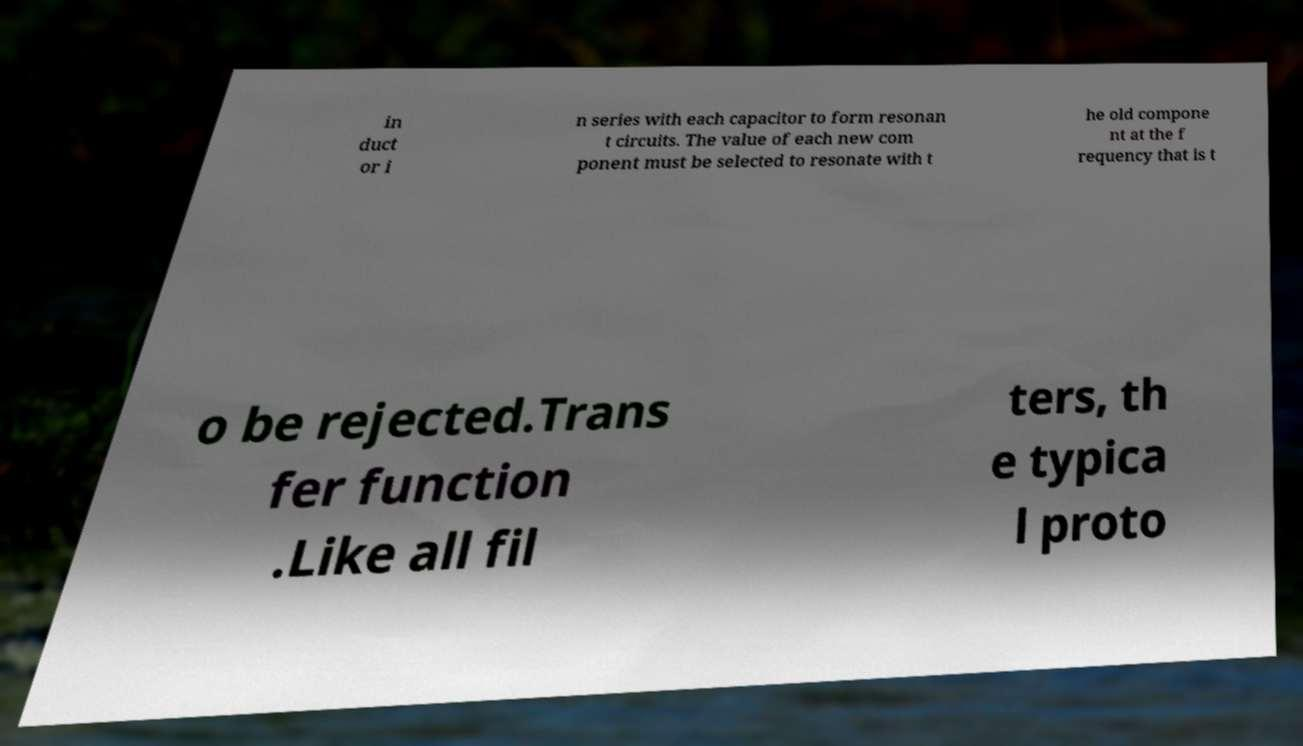Please identify and transcribe the text found in this image. in duct or i n series with each capacitor to form resonan t circuits. The value of each new com ponent must be selected to resonate with t he old compone nt at the f requency that is t o be rejected.Trans fer function .Like all fil ters, th e typica l proto 